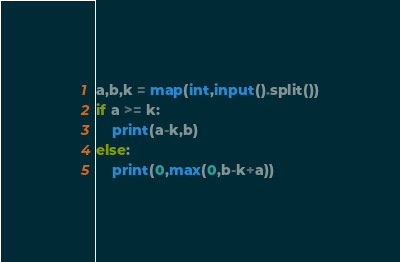Convert code to text. <code><loc_0><loc_0><loc_500><loc_500><_Python_>a,b,k = map(int,input().split())
if a >= k:
    print(a-k,b)
else:
    print(0,max(0,b-k+a))</code> 